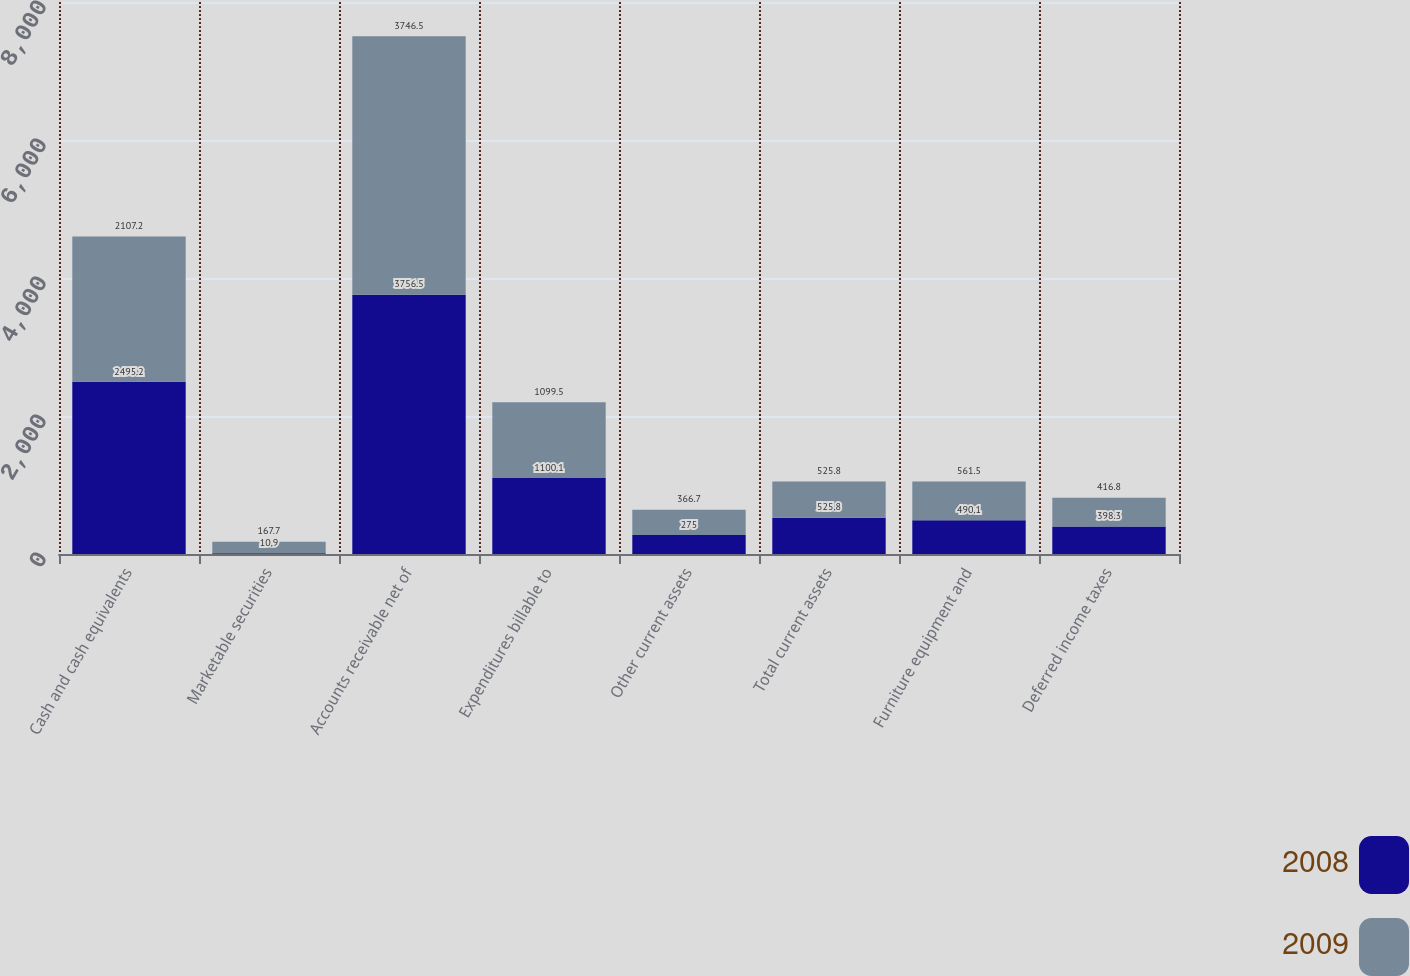Convert chart to OTSL. <chart><loc_0><loc_0><loc_500><loc_500><stacked_bar_chart><ecel><fcel>Cash and cash equivalents<fcel>Marketable securities<fcel>Accounts receivable net of<fcel>Expenditures billable to<fcel>Other current assets<fcel>Total current assets<fcel>Furniture equipment and<fcel>Deferred income taxes<nl><fcel>2008<fcel>2495.2<fcel>10.9<fcel>3756.5<fcel>1100.1<fcel>275<fcel>525.8<fcel>490.1<fcel>398.3<nl><fcel>2009<fcel>2107.2<fcel>167.7<fcel>3746.5<fcel>1099.5<fcel>366.7<fcel>525.8<fcel>561.5<fcel>416.8<nl></chart> 